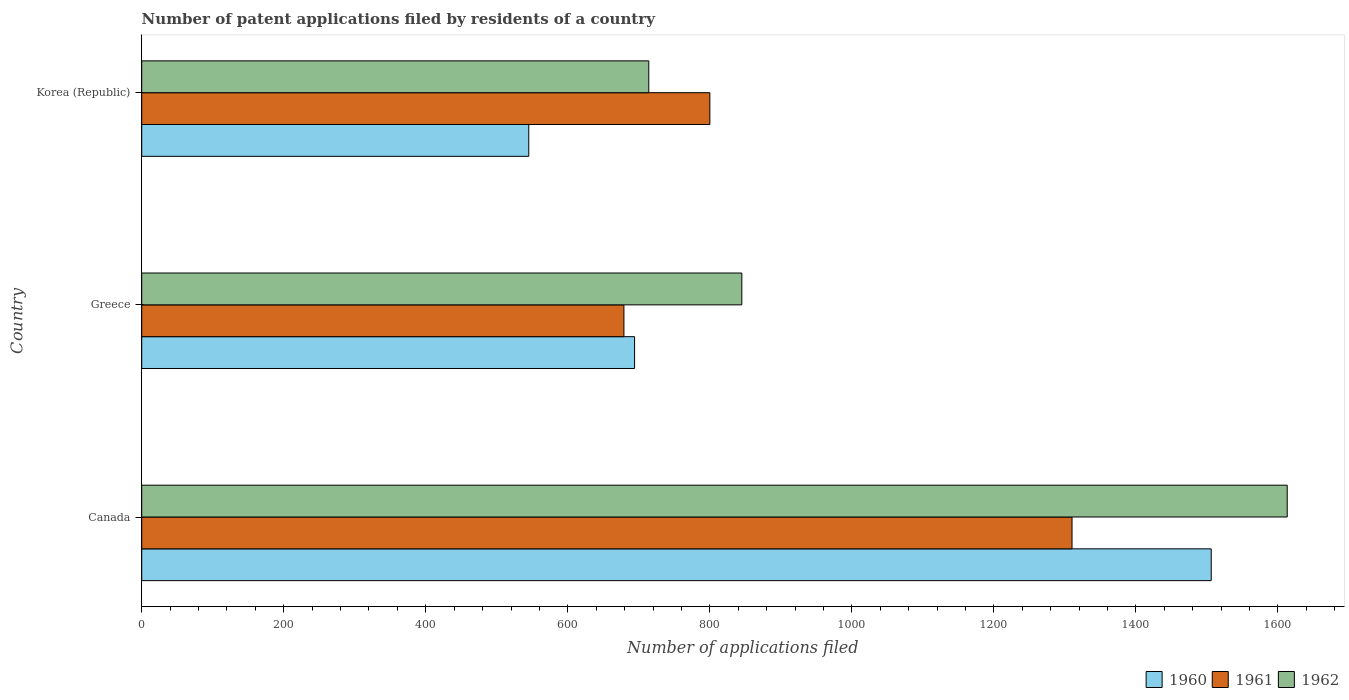How many different coloured bars are there?
Make the answer very short. 3. How many groups of bars are there?
Your response must be concise. 3. Are the number of bars per tick equal to the number of legend labels?
Your response must be concise. Yes. Are the number of bars on each tick of the Y-axis equal?
Provide a short and direct response. Yes. How many bars are there on the 1st tick from the bottom?
Your response must be concise. 3. In how many cases, is the number of bars for a given country not equal to the number of legend labels?
Your answer should be compact. 0. What is the number of applications filed in 1960 in Canada?
Provide a short and direct response. 1506. Across all countries, what is the maximum number of applications filed in 1960?
Keep it short and to the point. 1506. Across all countries, what is the minimum number of applications filed in 1960?
Offer a terse response. 545. In which country was the number of applications filed in 1960 maximum?
Keep it short and to the point. Canada. In which country was the number of applications filed in 1961 minimum?
Your answer should be compact. Greece. What is the total number of applications filed in 1960 in the graph?
Your answer should be compact. 2745. What is the difference between the number of applications filed in 1960 in Canada and that in Korea (Republic)?
Make the answer very short. 961. What is the difference between the number of applications filed in 1961 in Greece and the number of applications filed in 1960 in Canada?
Keep it short and to the point. -827. What is the average number of applications filed in 1962 per country?
Give a very brief answer. 1057.33. What is the difference between the number of applications filed in 1960 and number of applications filed in 1961 in Canada?
Provide a succinct answer. 196. In how many countries, is the number of applications filed in 1961 greater than 400 ?
Make the answer very short. 3. What is the ratio of the number of applications filed in 1962 in Canada to that in Greece?
Give a very brief answer. 1.91. What is the difference between the highest and the second highest number of applications filed in 1962?
Give a very brief answer. 768. What is the difference between the highest and the lowest number of applications filed in 1961?
Offer a very short reply. 631. Is the sum of the number of applications filed in 1960 in Greece and Korea (Republic) greater than the maximum number of applications filed in 1961 across all countries?
Offer a terse response. No. What does the 2nd bar from the bottom in Korea (Republic) represents?
Give a very brief answer. 1961. How many bars are there?
Ensure brevity in your answer.  9. Are all the bars in the graph horizontal?
Offer a terse response. Yes. What is the difference between two consecutive major ticks on the X-axis?
Your answer should be very brief. 200. Are the values on the major ticks of X-axis written in scientific E-notation?
Make the answer very short. No. Where does the legend appear in the graph?
Your answer should be very brief. Bottom right. How many legend labels are there?
Make the answer very short. 3. How are the legend labels stacked?
Your answer should be very brief. Horizontal. What is the title of the graph?
Your answer should be very brief. Number of patent applications filed by residents of a country. Does "2002" appear as one of the legend labels in the graph?
Ensure brevity in your answer.  No. What is the label or title of the X-axis?
Offer a very short reply. Number of applications filed. What is the Number of applications filed of 1960 in Canada?
Your answer should be compact. 1506. What is the Number of applications filed of 1961 in Canada?
Provide a short and direct response. 1310. What is the Number of applications filed in 1962 in Canada?
Ensure brevity in your answer.  1613. What is the Number of applications filed of 1960 in Greece?
Offer a terse response. 694. What is the Number of applications filed in 1961 in Greece?
Provide a succinct answer. 679. What is the Number of applications filed in 1962 in Greece?
Keep it short and to the point. 845. What is the Number of applications filed in 1960 in Korea (Republic)?
Provide a short and direct response. 545. What is the Number of applications filed in 1961 in Korea (Republic)?
Offer a terse response. 800. What is the Number of applications filed in 1962 in Korea (Republic)?
Provide a short and direct response. 714. Across all countries, what is the maximum Number of applications filed of 1960?
Your response must be concise. 1506. Across all countries, what is the maximum Number of applications filed of 1961?
Offer a terse response. 1310. Across all countries, what is the maximum Number of applications filed of 1962?
Offer a terse response. 1613. Across all countries, what is the minimum Number of applications filed in 1960?
Keep it short and to the point. 545. Across all countries, what is the minimum Number of applications filed of 1961?
Your response must be concise. 679. Across all countries, what is the minimum Number of applications filed in 1962?
Your response must be concise. 714. What is the total Number of applications filed of 1960 in the graph?
Make the answer very short. 2745. What is the total Number of applications filed in 1961 in the graph?
Offer a terse response. 2789. What is the total Number of applications filed in 1962 in the graph?
Your answer should be very brief. 3172. What is the difference between the Number of applications filed in 1960 in Canada and that in Greece?
Your response must be concise. 812. What is the difference between the Number of applications filed of 1961 in Canada and that in Greece?
Ensure brevity in your answer.  631. What is the difference between the Number of applications filed in 1962 in Canada and that in Greece?
Ensure brevity in your answer.  768. What is the difference between the Number of applications filed of 1960 in Canada and that in Korea (Republic)?
Your answer should be very brief. 961. What is the difference between the Number of applications filed in 1961 in Canada and that in Korea (Republic)?
Your response must be concise. 510. What is the difference between the Number of applications filed of 1962 in Canada and that in Korea (Republic)?
Keep it short and to the point. 899. What is the difference between the Number of applications filed of 1960 in Greece and that in Korea (Republic)?
Provide a succinct answer. 149. What is the difference between the Number of applications filed in 1961 in Greece and that in Korea (Republic)?
Offer a very short reply. -121. What is the difference between the Number of applications filed of 1962 in Greece and that in Korea (Republic)?
Offer a terse response. 131. What is the difference between the Number of applications filed of 1960 in Canada and the Number of applications filed of 1961 in Greece?
Your response must be concise. 827. What is the difference between the Number of applications filed in 1960 in Canada and the Number of applications filed in 1962 in Greece?
Your response must be concise. 661. What is the difference between the Number of applications filed in 1961 in Canada and the Number of applications filed in 1962 in Greece?
Provide a succinct answer. 465. What is the difference between the Number of applications filed of 1960 in Canada and the Number of applications filed of 1961 in Korea (Republic)?
Provide a short and direct response. 706. What is the difference between the Number of applications filed in 1960 in Canada and the Number of applications filed in 1962 in Korea (Republic)?
Offer a very short reply. 792. What is the difference between the Number of applications filed of 1961 in Canada and the Number of applications filed of 1962 in Korea (Republic)?
Give a very brief answer. 596. What is the difference between the Number of applications filed of 1960 in Greece and the Number of applications filed of 1961 in Korea (Republic)?
Your answer should be compact. -106. What is the difference between the Number of applications filed in 1960 in Greece and the Number of applications filed in 1962 in Korea (Republic)?
Give a very brief answer. -20. What is the difference between the Number of applications filed in 1961 in Greece and the Number of applications filed in 1962 in Korea (Republic)?
Give a very brief answer. -35. What is the average Number of applications filed of 1960 per country?
Your answer should be very brief. 915. What is the average Number of applications filed in 1961 per country?
Your response must be concise. 929.67. What is the average Number of applications filed in 1962 per country?
Ensure brevity in your answer.  1057.33. What is the difference between the Number of applications filed of 1960 and Number of applications filed of 1961 in Canada?
Ensure brevity in your answer.  196. What is the difference between the Number of applications filed in 1960 and Number of applications filed in 1962 in Canada?
Your answer should be very brief. -107. What is the difference between the Number of applications filed of 1961 and Number of applications filed of 1962 in Canada?
Your answer should be compact. -303. What is the difference between the Number of applications filed of 1960 and Number of applications filed of 1962 in Greece?
Your answer should be very brief. -151. What is the difference between the Number of applications filed in 1961 and Number of applications filed in 1962 in Greece?
Your answer should be compact. -166. What is the difference between the Number of applications filed in 1960 and Number of applications filed in 1961 in Korea (Republic)?
Make the answer very short. -255. What is the difference between the Number of applications filed of 1960 and Number of applications filed of 1962 in Korea (Republic)?
Offer a very short reply. -169. What is the ratio of the Number of applications filed of 1960 in Canada to that in Greece?
Give a very brief answer. 2.17. What is the ratio of the Number of applications filed of 1961 in Canada to that in Greece?
Give a very brief answer. 1.93. What is the ratio of the Number of applications filed in 1962 in Canada to that in Greece?
Offer a terse response. 1.91. What is the ratio of the Number of applications filed of 1960 in Canada to that in Korea (Republic)?
Make the answer very short. 2.76. What is the ratio of the Number of applications filed of 1961 in Canada to that in Korea (Republic)?
Make the answer very short. 1.64. What is the ratio of the Number of applications filed of 1962 in Canada to that in Korea (Republic)?
Make the answer very short. 2.26. What is the ratio of the Number of applications filed of 1960 in Greece to that in Korea (Republic)?
Your answer should be compact. 1.27. What is the ratio of the Number of applications filed of 1961 in Greece to that in Korea (Republic)?
Your answer should be very brief. 0.85. What is the ratio of the Number of applications filed in 1962 in Greece to that in Korea (Republic)?
Make the answer very short. 1.18. What is the difference between the highest and the second highest Number of applications filed in 1960?
Offer a very short reply. 812. What is the difference between the highest and the second highest Number of applications filed of 1961?
Offer a very short reply. 510. What is the difference between the highest and the second highest Number of applications filed of 1962?
Your answer should be very brief. 768. What is the difference between the highest and the lowest Number of applications filed of 1960?
Provide a succinct answer. 961. What is the difference between the highest and the lowest Number of applications filed in 1961?
Keep it short and to the point. 631. What is the difference between the highest and the lowest Number of applications filed of 1962?
Your answer should be very brief. 899. 